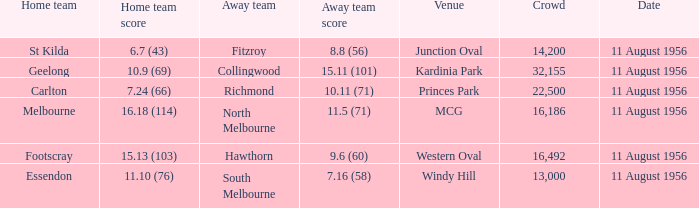What home team played at western oval? Footscray. 